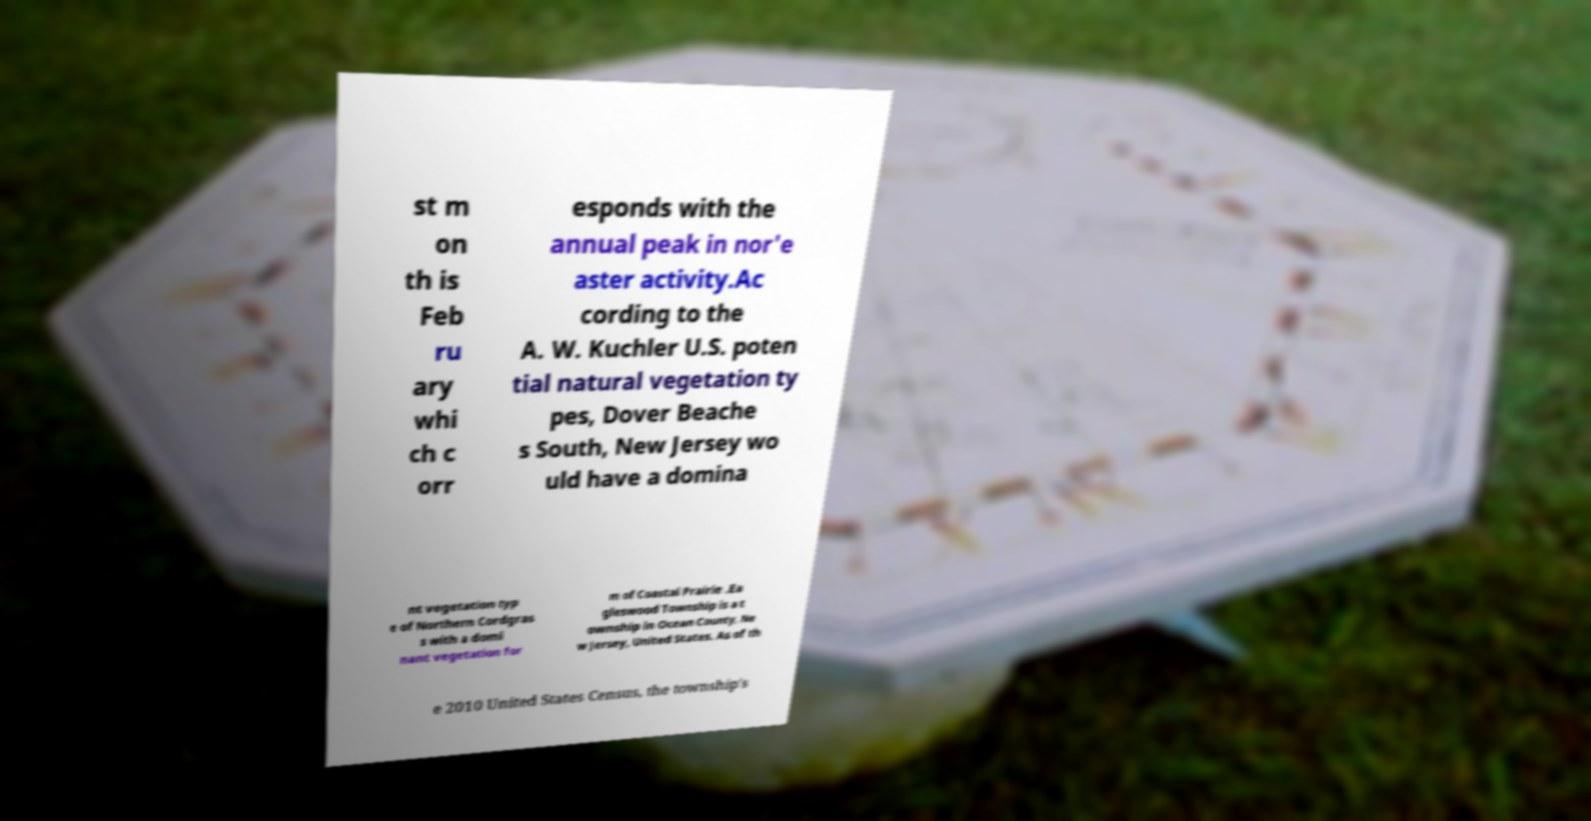Could you assist in decoding the text presented in this image and type it out clearly? st m on th is Feb ru ary whi ch c orr esponds with the annual peak in nor'e aster activity.Ac cording to the A. W. Kuchler U.S. poten tial natural vegetation ty pes, Dover Beache s South, New Jersey wo uld have a domina nt vegetation typ e of Northern Cordgras s with a domi nant vegetation for m of Coastal Prairie .Ea gleswood Township is a t ownship in Ocean County, Ne w Jersey, United States. As of th e 2010 United States Census, the township's 